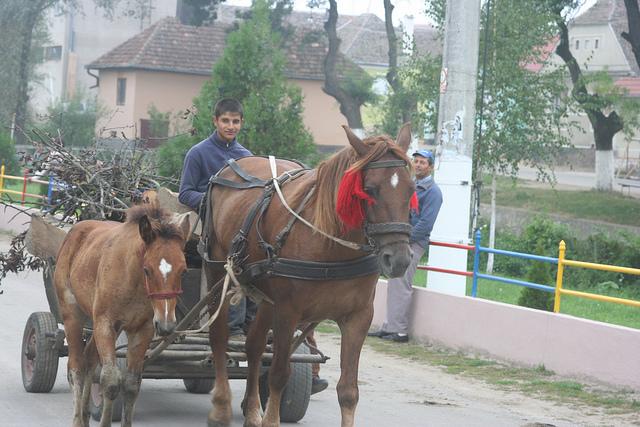What is the horse and pony pulling?
Write a very short answer. Cart. What is in the cart being pulled by the horse and pony?
Keep it brief. Branches. What marking do both horses share?
Give a very brief answer. White. 